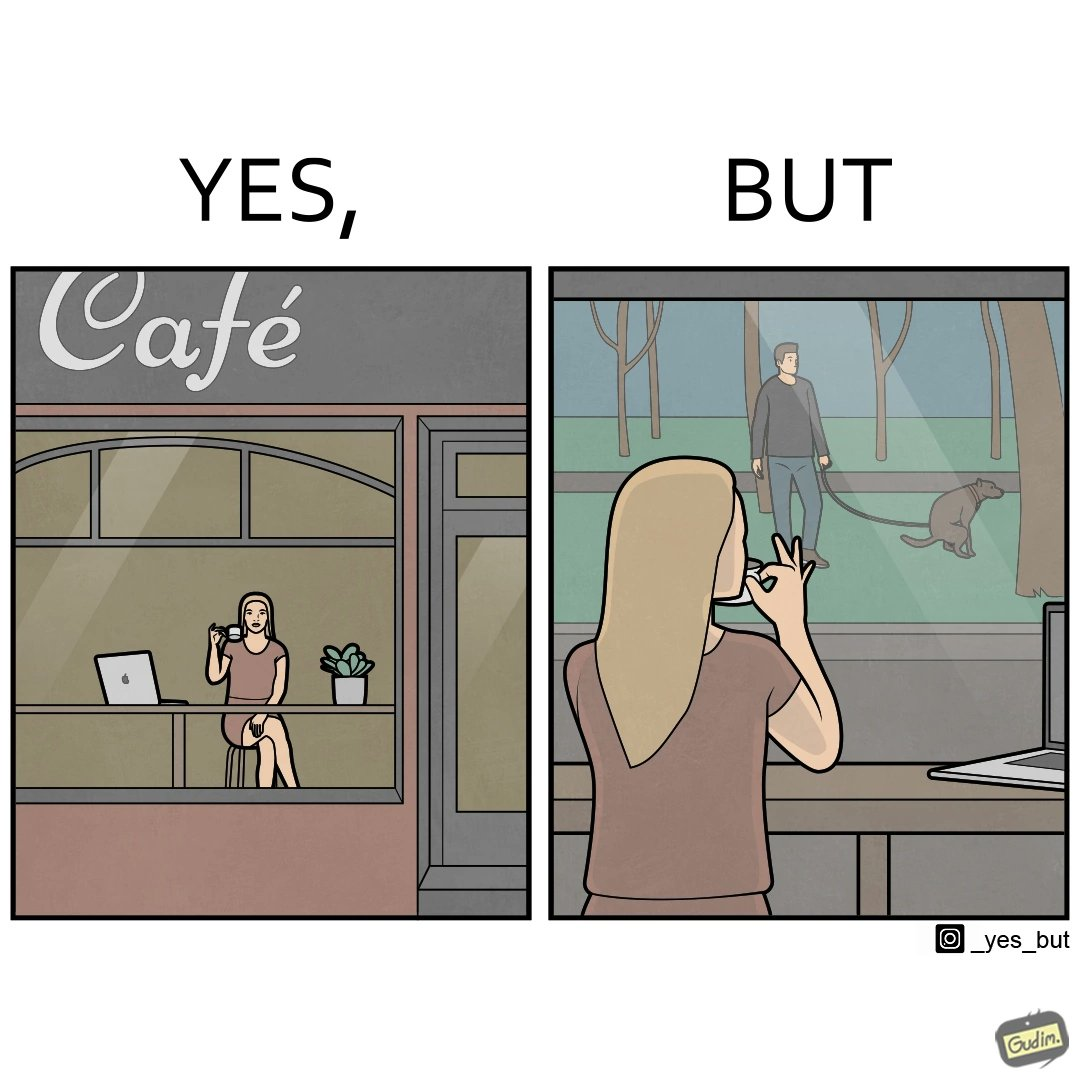Describe the content of this image. The image is ironic, because in the first image the woman is seen as enjoying the view but in the second image the same woman is seen as looking at a pooping dog 